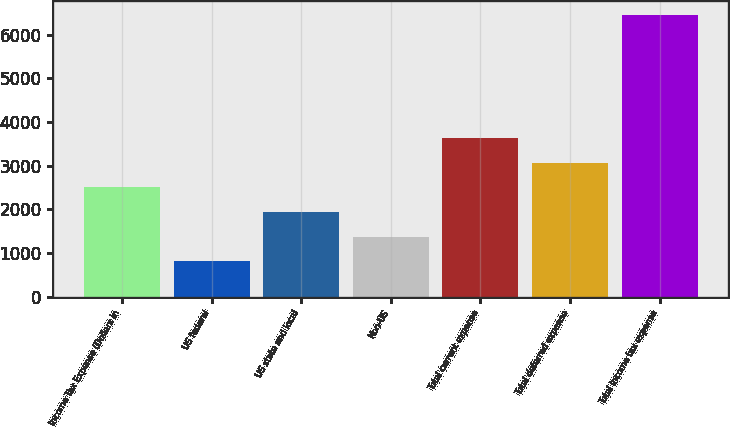Convert chart. <chart><loc_0><loc_0><loc_500><loc_500><bar_chart><fcel>Income Tax Expense (Dollars in<fcel>US federal<fcel>US state and local<fcel>Non-US<fcel>Total current expense<fcel>Total deferred expense<fcel>Total income tax expense<nl><fcel>2502.3<fcel>816<fcel>1940.2<fcel>1378.1<fcel>3626.5<fcel>3064.4<fcel>6437<nl></chart> 